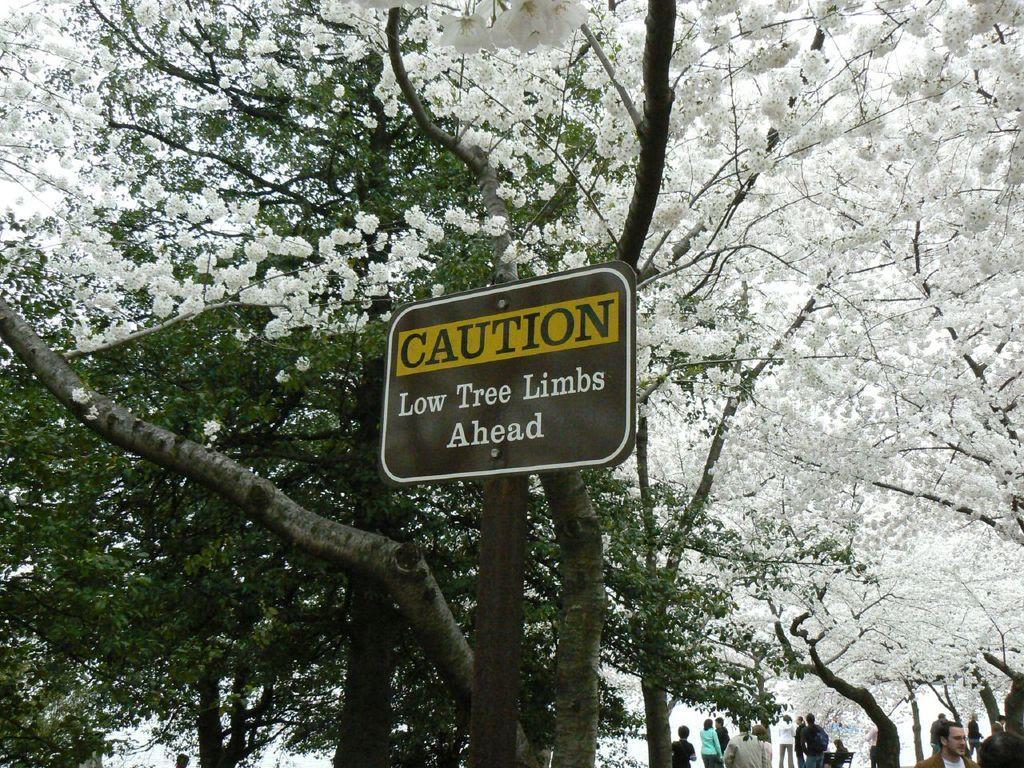How would you summarize this image in a sentence or two? In this picture there are people, among them there is a person sitting on a bench and we can see board, trees and flowers. 